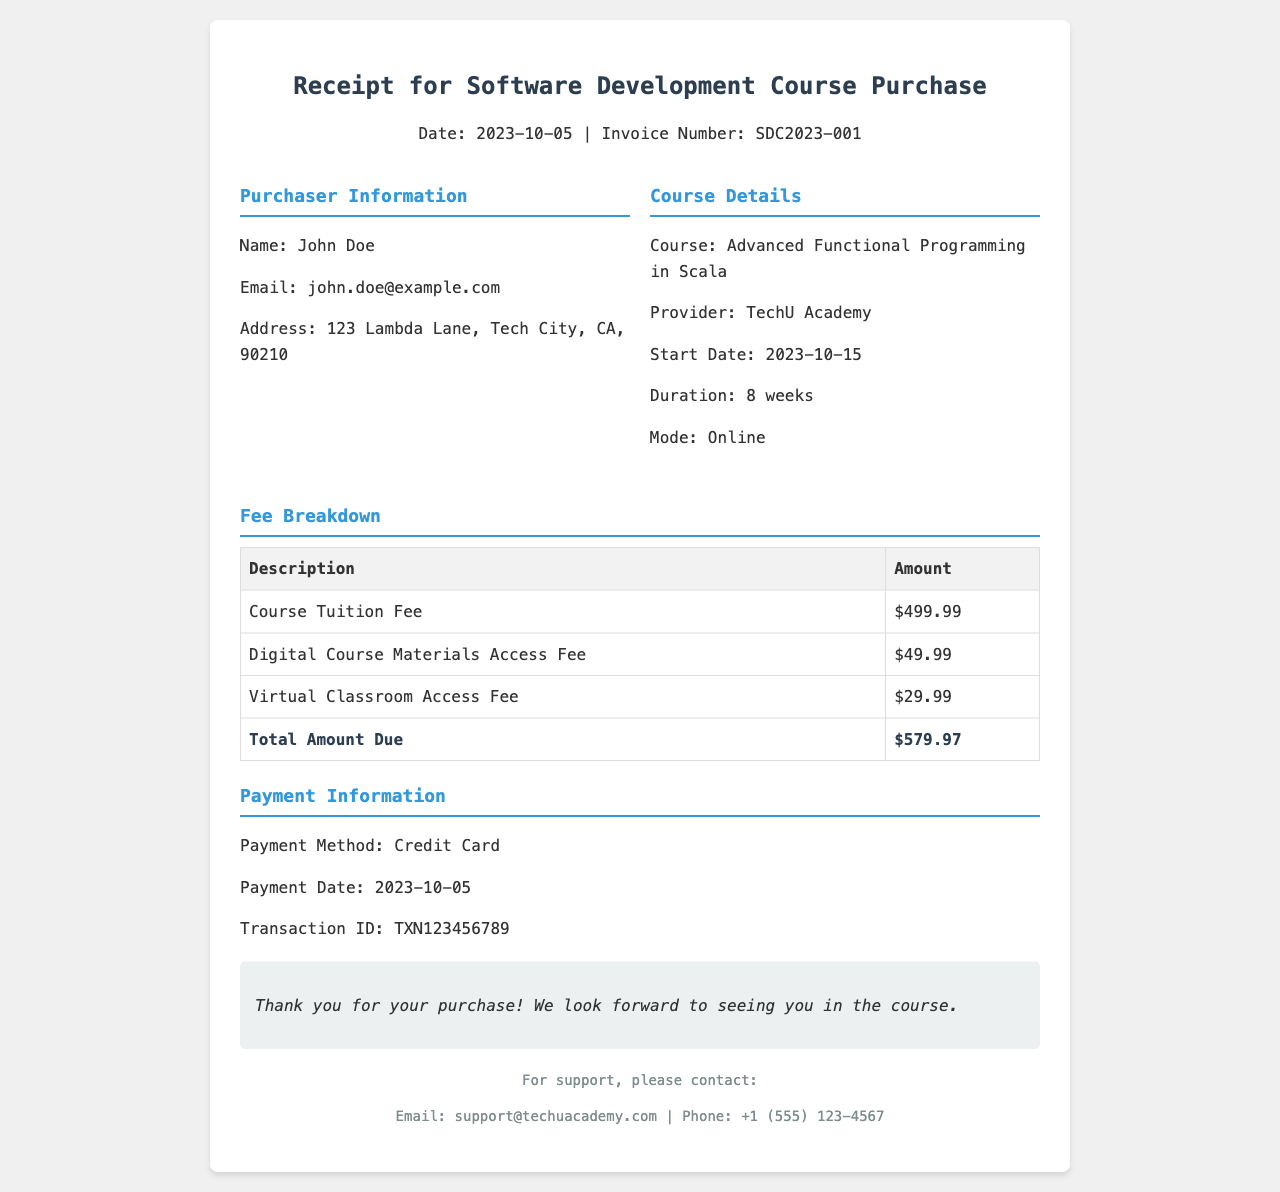What is the date of the purchase? The date mentioned in the receipt is the date when the purchase was made, which is shown as 2023-10-05.
Answer: 2023-10-05 Who is the purchaser? The receipt provides the name of the individual who made the purchase, which is given as John Doe.
Answer: John Doe What is the course title? The title of the course purchased is essential information, which is specified as Advanced Functional Programming in Scala.
Answer: Advanced Functional Programming in Scala What is the total amount due? This is calculated by summing all the fees listed in the breakdown. The total amount is highlighted in the section as $579.97.
Answer: $579.97 What is the payment method? The method used to make the payment is mentioned in the receipt, which is indicated as Credit Card.
Answer: Credit Card How long is the course duration? The receipt specifies the length of the course, which is stated as 8 weeks.
Answer: 8 weeks What is the email address for support? The receipt provides contact information for support; the email is stated as support@techuacademy.com.
Answer: support@techuacademy.com When does the course start? The starting date of the course is mentioned in the course details section as 2023-10-15.
Answer: 2023-10-15 What is the transaction ID? The transaction ID is a unique identifier for the payment, which is specified in the document as TXN123456789.
Answer: TXN123456789 